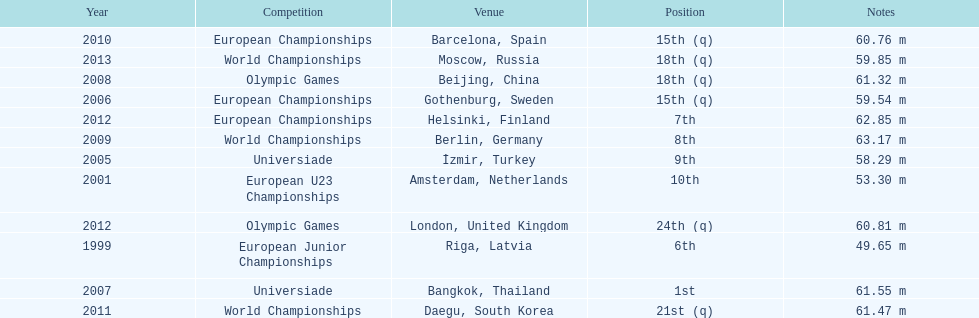What was mayer's best result: i.e his longest throw? 63.17 m. 